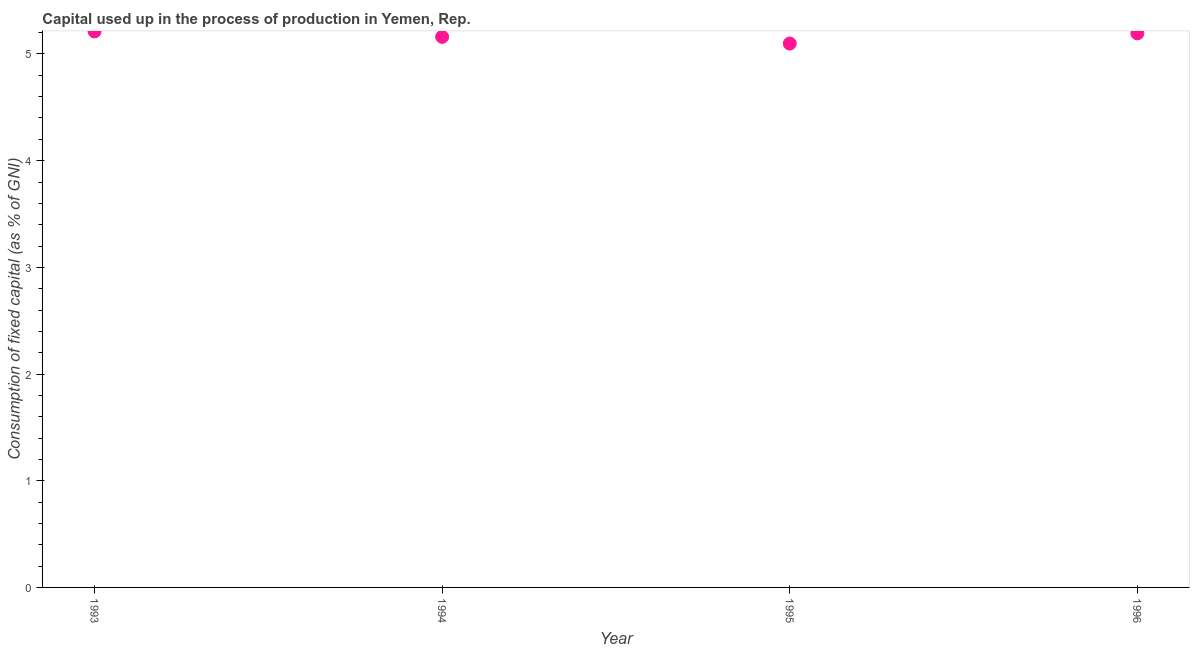What is the consumption of fixed capital in 1996?
Offer a very short reply. 5.19. Across all years, what is the maximum consumption of fixed capital?
Provide a short and direct response. 5.21. Across all years, what is the minimum consumption of fixed capital?
Your response must be concise. 5.1. In which year was the consumption of fixed capital maximum?
Give a very brief answer. 1993. In which year was the consumption of fixed capital minimum?
Offer a terse response. 1995. What is the sum of the consumption of fixed capital?
Make the answer very short. 20.66. What is the difference between the consumption of fixed capital in 1993 and 1995?
Keep it short and to the point. 0.11. What is the average consumption of fixed capital per year?
Your answer should be very brief. 5.17. What is the median consumption of fixed capital?
Your response must be concise. 5.18. In how many years, is the consumption of fixed capital greater than 2.6 %?
Keep it short and to the point. 4. Do a majority of the years between 1993 and 1994 (inclusive) have consumption of fixed capital greater than 3.6 %?
Make the answer very short. Yes. What is the ratio of the consumption of fixed capital in 1994 to that in 1996?
Offer a very short reply. 0.99. Is the consumption of fixed capital in 1994 less than that in 1996?
Provide a succinct answer. Yes. Is the difference between the consumption of fixed capital in 1993 and 1995 greater than the difference between any two years?
Provide a short and direct response. Yes. What is the difference between the highest and the second highest consumption of fixed capital?
Keep it short and to the point. 0.02. What is the difference between the highest and the lowest consumption of fixed capital?
Your answer should be very brief. 0.11. Does the consumption of fixed capital monotonically increase over the years?
Ensure brevity in your answer.  No. How many dotlines are there?
Keep it short and to the point. 1. Are the values on the major ticks of Y-axis written in scientific E-notation?
Ensure brevity in your answer.  No. Does the graph contain any zero values?
Keep it short and to the point. No. What is the title of the graph?
Offer a terse response. Capital used up in the process of production in Yemen, Rep. What is the label or title of the X-axis?
Make the answer very short. Year. What is the label or title of the Y-axis?
Your answer should be compact. Consumption of fixed capital (as % of GNI). What is the Consumption of fixed capital (as % of GNI) in 1993?
Keep it short and to the point. 5.21. What is the Consumption of fixed capital (as % of GNI) in 1994?
Offer a terse response. 5.16. What is the Consumption of fixed capital (as % of GNI) in 1995?
Provide a succinct answer. 5.1. What is the Consumption of fixed capital (as % of GNI) in 1996?
Your answer should be very brief. 5.19. What is the difference between the Consumption of fixed capital (as % of GNI) in 1993 and 1994?
Provide a succinct answer. 0.05. What is the difference between the Consumption of fixed capital (as % of GNI) in 1993 and 1995?
Make the answer very short. 0.11. What is the difference between the Consumption of fixed capital (as % of GNI) in 1993 and 1996?
Make the answer very short. 0.02. What is the difference between the Consumption of fixed capital (as % of GNI) in 1994 and 1995?
Your response must be concise. 0.06. What is the difference between the Consumption of fixed capital (as % of GNI) in 1994 and 1996?
Provide a succinct answer. -0.03. What is the difference between the Consumption of fixed capital (as % of GNI) in 1995 and 1996?
Ensure brevity in your answer.  -0.1. What is the ratio of the Consumption of fixed capital (as % of GNI) in 1993 to that in 1994?
Your answer should be compact. 1.01. What is the ratio of the Consumption of fixed capital (as % of GNI) in 1993 to that in 1995?
Offer a very short reply. 1.02. What is the ratio of the Consumption of fixed capital (as % of GNI) in 1994 to that in 1995?
Ensure brevity in your answer.  1.01. What is the ratio of the Consumption of fixed capital (as % of GNI) in 1995 to that in 1996?
Offer a very short reply. 0.98. 